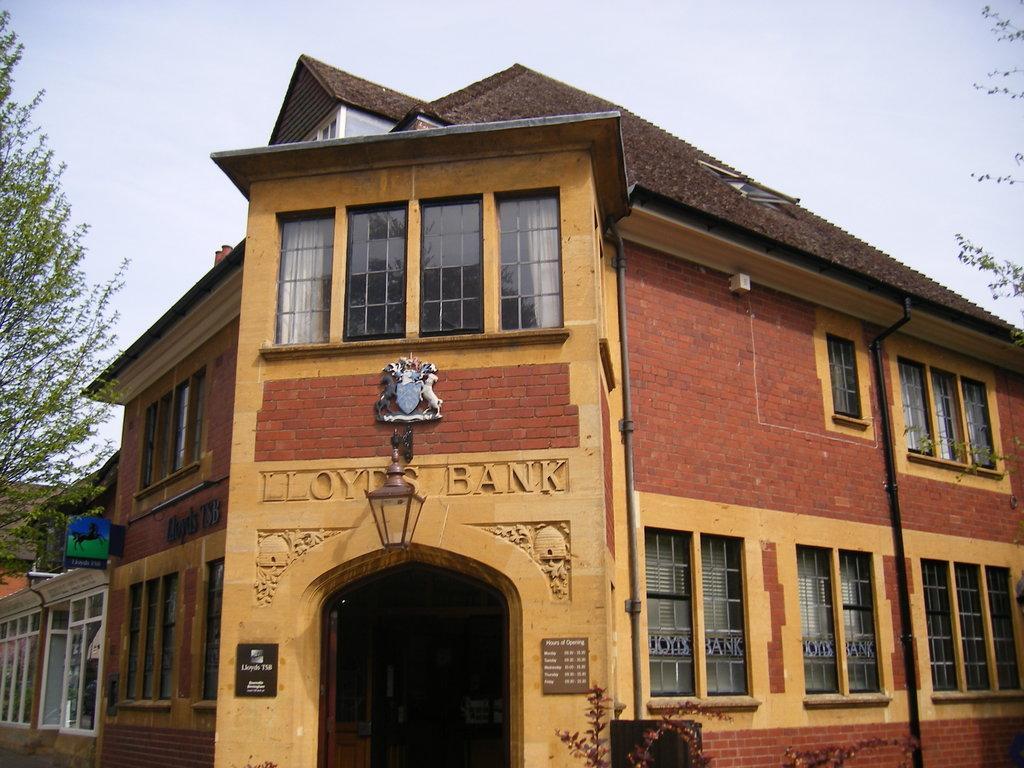In one or two sentences, can you explain what this image depicts? In this picture I can see there is a building and it has a door, windows and there is a tree at right and left sides. There is a label on the windows at right and there are few more buildings at left side. The sky is clear. 